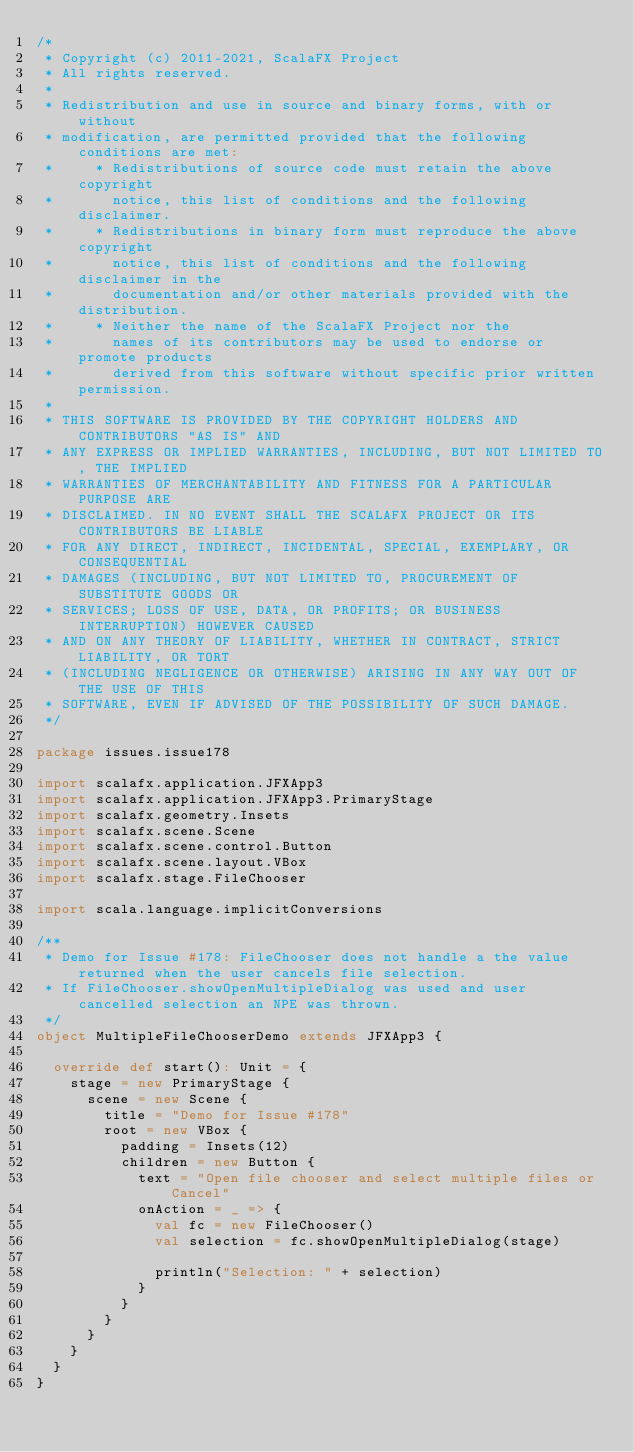<code> <loc_0><loc_0><loc_500><loc_500><_Scala_>/*
 * Copyright (c) 2011-2021, ScalaFX Project
 * All rights reserved.
 *
 * Redistribution and use in source and binary forms, with or without
 * modification, are permitted provided that the following conditions are met:
 *     * Redistributions of source code must retain the above copyright
 *       notice, this list of conditions and the following disclaimer.
 *     * Redistributions in binary form must reproduce the above copyright
 *       notice, this list of conditions and the following disclaimer in the
 *       documentation and/or other materials provided with the distribution.
 *     * Neither the name of the ScalaFX Project nor the
 *       names of its contributors may be used to endorse or promote products
 *       derived from this software without specific prior written permission.
 *
 * THIS SOFTWARE IS PROVIDED BY THE COPYRIGHT HOLDERS AND CONTRIBUTORS "AS IS" AND
 * ANY EXPRESS OR IMPLIED WARRANTIES, INCLUDING, BUT NOT LIMITED TO, THE IMPLIED
 * WARRANTIES OF MERCHANTABILITY AND FITNESS FOR A PARTICULAR PURPOSE ARE
 * DISCLAIMED. IN NO EVENT SHALL THE SCALAFX PROJECT OR ITS CONTRIBUTORS BE LIABLE
 * FOR ANY DIRECT, INDIRECT, INCIDENTAL, SPECIAL, EXEMPLARY, OR CONSEQUENTIAL
 * DAMAGES (INCLUDING, BUT NOT LIMITED TO, PROCUREMENT OF SUBSTITUTE GOODS OR
 * SERVICES; LOSS OF USE, DATA, OR PROFITS; OR BUSINESS INTERRUPTION) HOWEVER CAUSED
 * AND ON ANY THEORY OF LIABILITY, WHETHER IN CONTRACT, STRICT LIABILITY, OR TORT
 * (INCLUDING NEGLIGENCE OR OTHERWISE) ARISING IN ANY WAY OUT OF THE USE OF THIS
 * SOFTWARE, EVEN IF ADVISED OF THE POSSIBILITY OF SUCH DAMAGE.
 */

package issues.issue178

import scalafx.application.JFXApp3
import scalafx.application.JFXApp3.PrimaryStage
import scalafx.geometry.Insets
import scalafx.scene.Scene
import scalafx.scene.control.Button
import scalafx.scene.layout.VBox
import scalafx.stage.FileChooser

import scala.language.implicitConversions

/**
 * Demo for Issue #178: FileChooser does not handle a the value returned when the user cancels file selection.
 * If FileChooser.showOpenMultipleDialog was used and user cancelled selection an NPE was thrown.
 */
object MultipleFileChooserDemo extends JFXApp3 {

  override def start(): Unit = {
    stage = new PrimaryStage {
      scene = new Scene {
        title = "Demo for Issue #178"
        root = new VBox {
          padding = Insets(12)
          children = new Button {
            text = "Open file chooser and select multiple files or Cancel"
            onAction = _ => {
              val fc = new FileChooser()
              val selection = fc.showOpenMultipleDialog(stage)

              println("Selection: " + selection)
            }
          }
        }
      }
    }
  }
}
</code> 